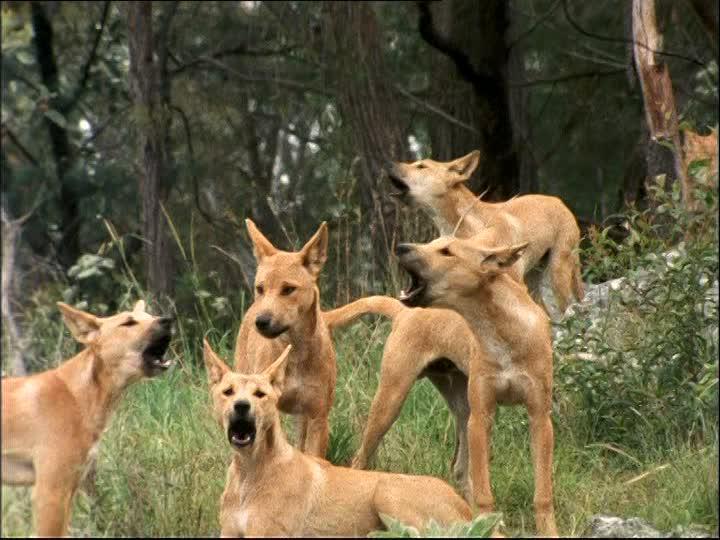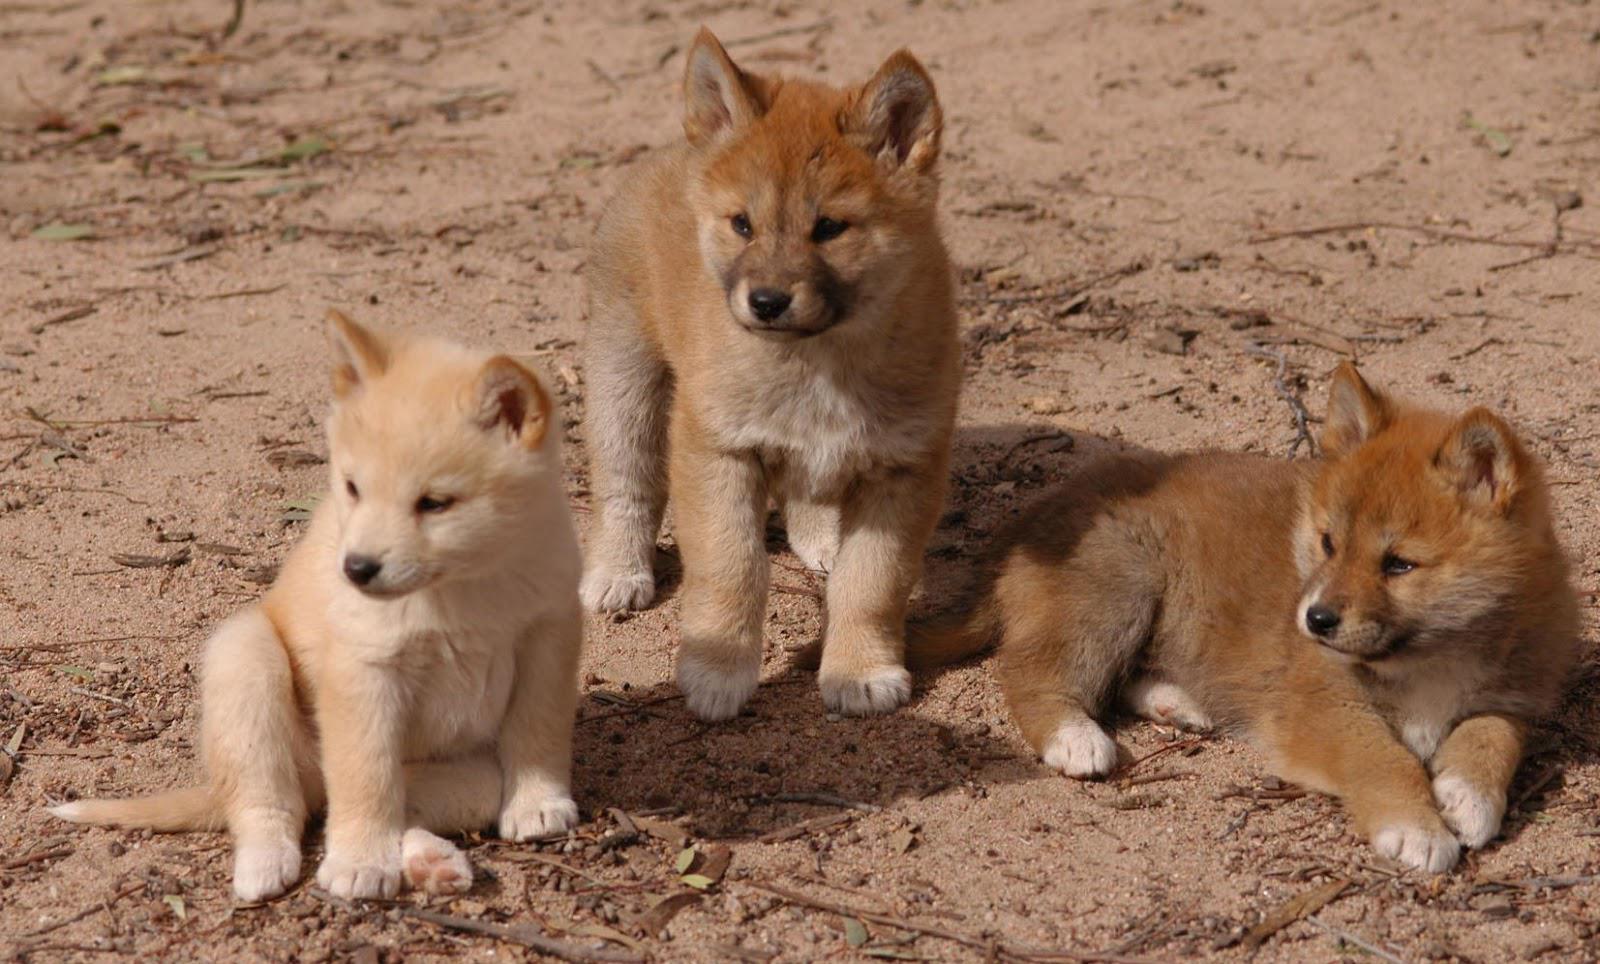The first image is the image on the left, the second image is the image on the right. For the images shown, is this caption "One animal is standing in the image on the left." true? Answer yes or no. No. The first image is the image on the left, the second image is the image on the right. Analyze the images presented: Is the assertion "There are more dogs in the right image than in the left." valid? Answer yes or no. No. 